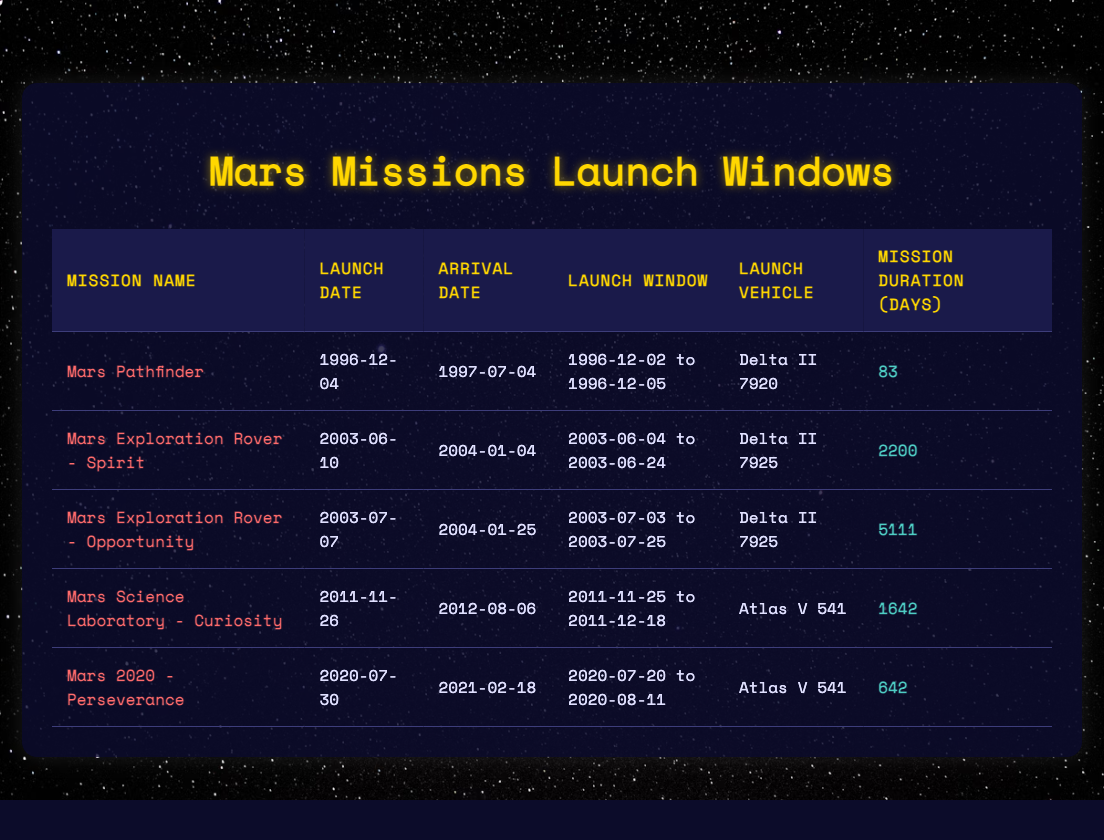What was the launch date of the Mars Science Laboratory - Curiosity? The launch date for the Mars Science Laboratory - Curiosity is listed in the table under the "Launch Date" column for that mission, which shows "2011-11-26."
Answer: 2011-11-26 Which mission had the longest duration, and how many days did it last? By examining the "Mission Duration (Days)" column, the mission with the longest duration is the Mars Exploration Rover - Opportunity, lasting 5111 days.
Answer: Mars Exploration Rover - Opportunity, 5111 days Was the launch window for Mars Pathfinder longer than that of Mars 2020 - Perseverance? The launch window for Mars Pathfinder is from 1996-12-02 to 1996-12-05, making it a total of 4 days. The launch window for Mars 2020 - Perseverance is from 2020-07-20 to 2020-08-11, totaling 23 days. Since 4 days is not longer than 23 days, the answer is no.
Answer: No What is the average mission duration of all Mars missions listed in the table? To calculate the average, sum all the mission durations: 83 + 2200 + 5111 + 1642 + 642 = 9400 days. Then divide by the number of missions (5): 9400 / 5 = 1880 days.
Answer: 1880 days Did any of the Mars missions use the Delta II 7925 as the launch vehicle? Checking the "Launch Vehicle" column shows that both the Mars Exploration Rover - Spirit and Mars Exploration Rover - Opportunity missions used the Delta II 7925. Hence, the answer is yes.
Answer: Yes 